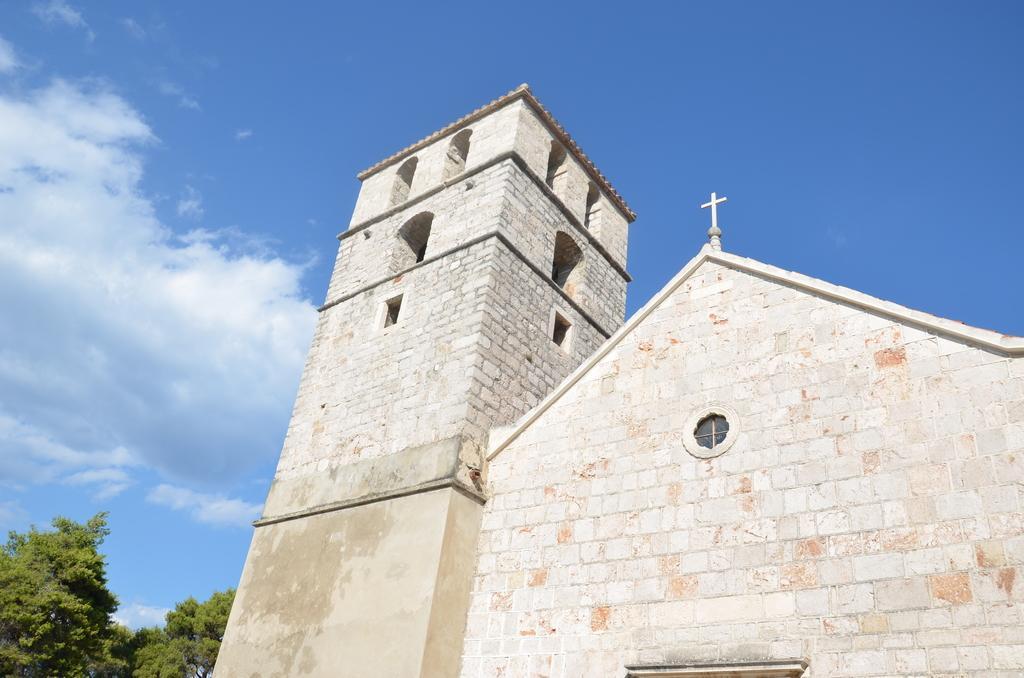Can you describe this image briefly? This picture is clicked outside. On the right we can see the buildings and the windows of the buildings. On the left we can see the trees. In the background we can see the sky with the clouds. 